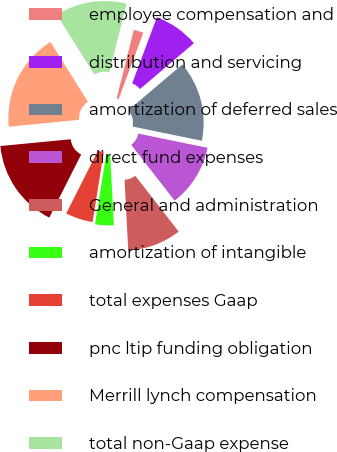Convert chart. <chart><loc_0><loc_0><loc_500><loc_500><pie_chart><fcel>employee compensation and<fcel>distribution and servicing<fcel>amortization of deferred sales<fcel>direct fund expenses<fcel>General and administration<fcel>amortization of intangible<fcel>total expenses Gaap<fcel>pnc ltip funding obligation<fcel>Merrill lynch compensation<fcel>total non-Gaap expense<nl><fcel>1.76%<fcel>8.1%<fcel>14.44%<fcel>11.27%<fcel>9.68%<fcel>3.35%<fcel>4.93%<fcel>16.02%<fcel>17.61%<fcel>12.85%<nl></chart> 